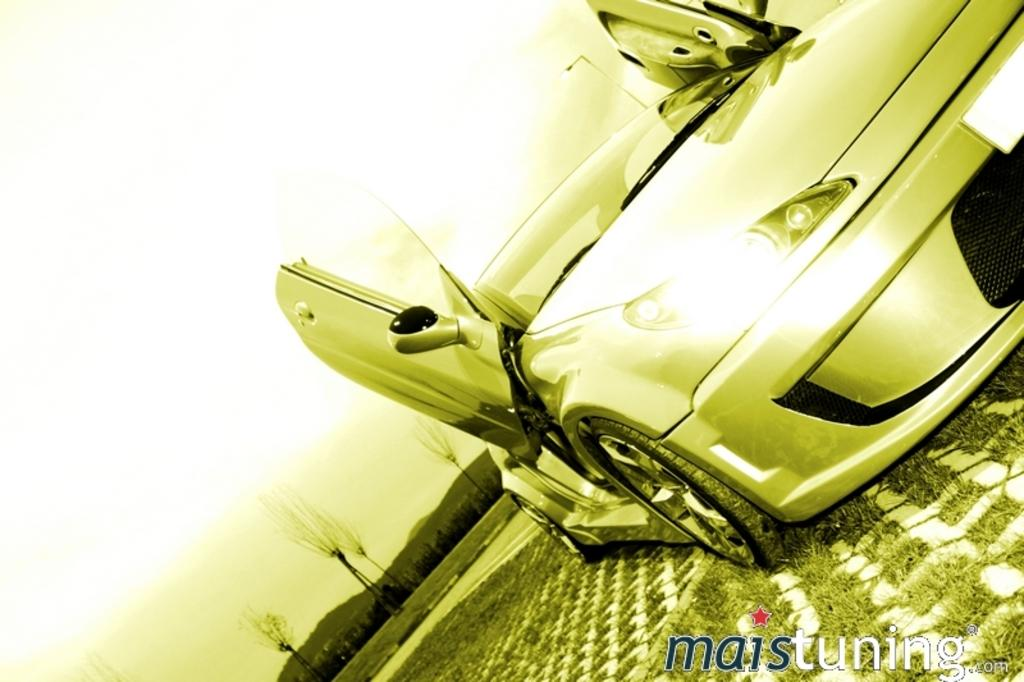What is the main subject of the image? There is a car in the image. What can be seen in the background of the image? There are trees and mountains in the background of the image. How would you describe the lighting in the image? There is a greenish color light in the image. What type of hammer is being used to write on the pen in the image? There is no hammer or pen present in the image, so this question cannot be answered. 